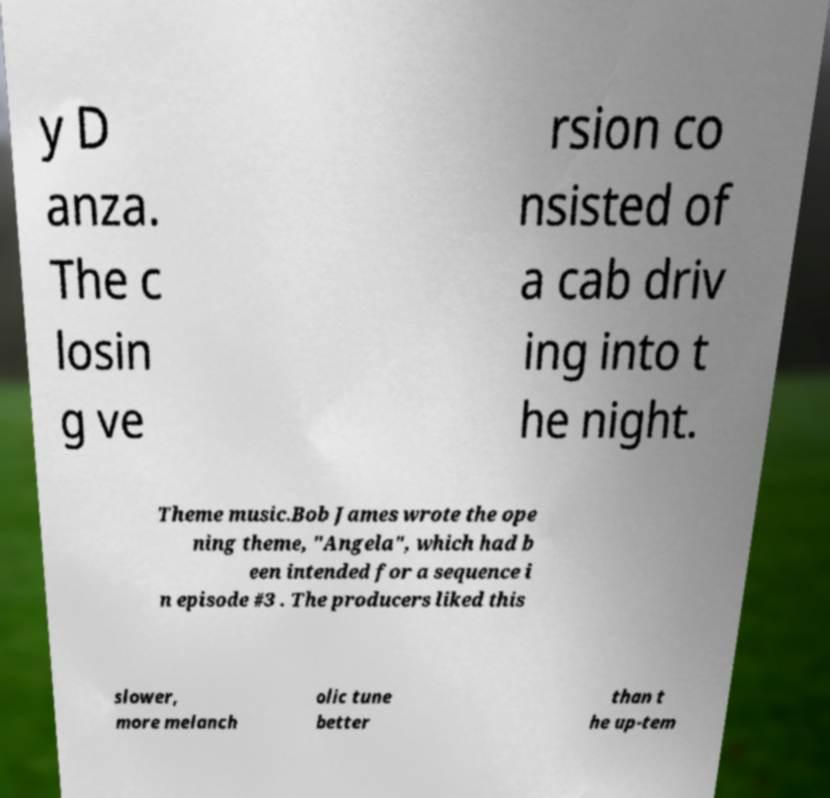Please identify and transcribe the text found in this image. y D anza. The c losin g ve rsion co nsisted of a cab driv ing into t he night. Theme music.Bob James wrote the ope ning theme, "Angela", which had b een intended for a sequence i n episode #3 . The producers liked this slower, more melanch olic tune better than t he up-tem 